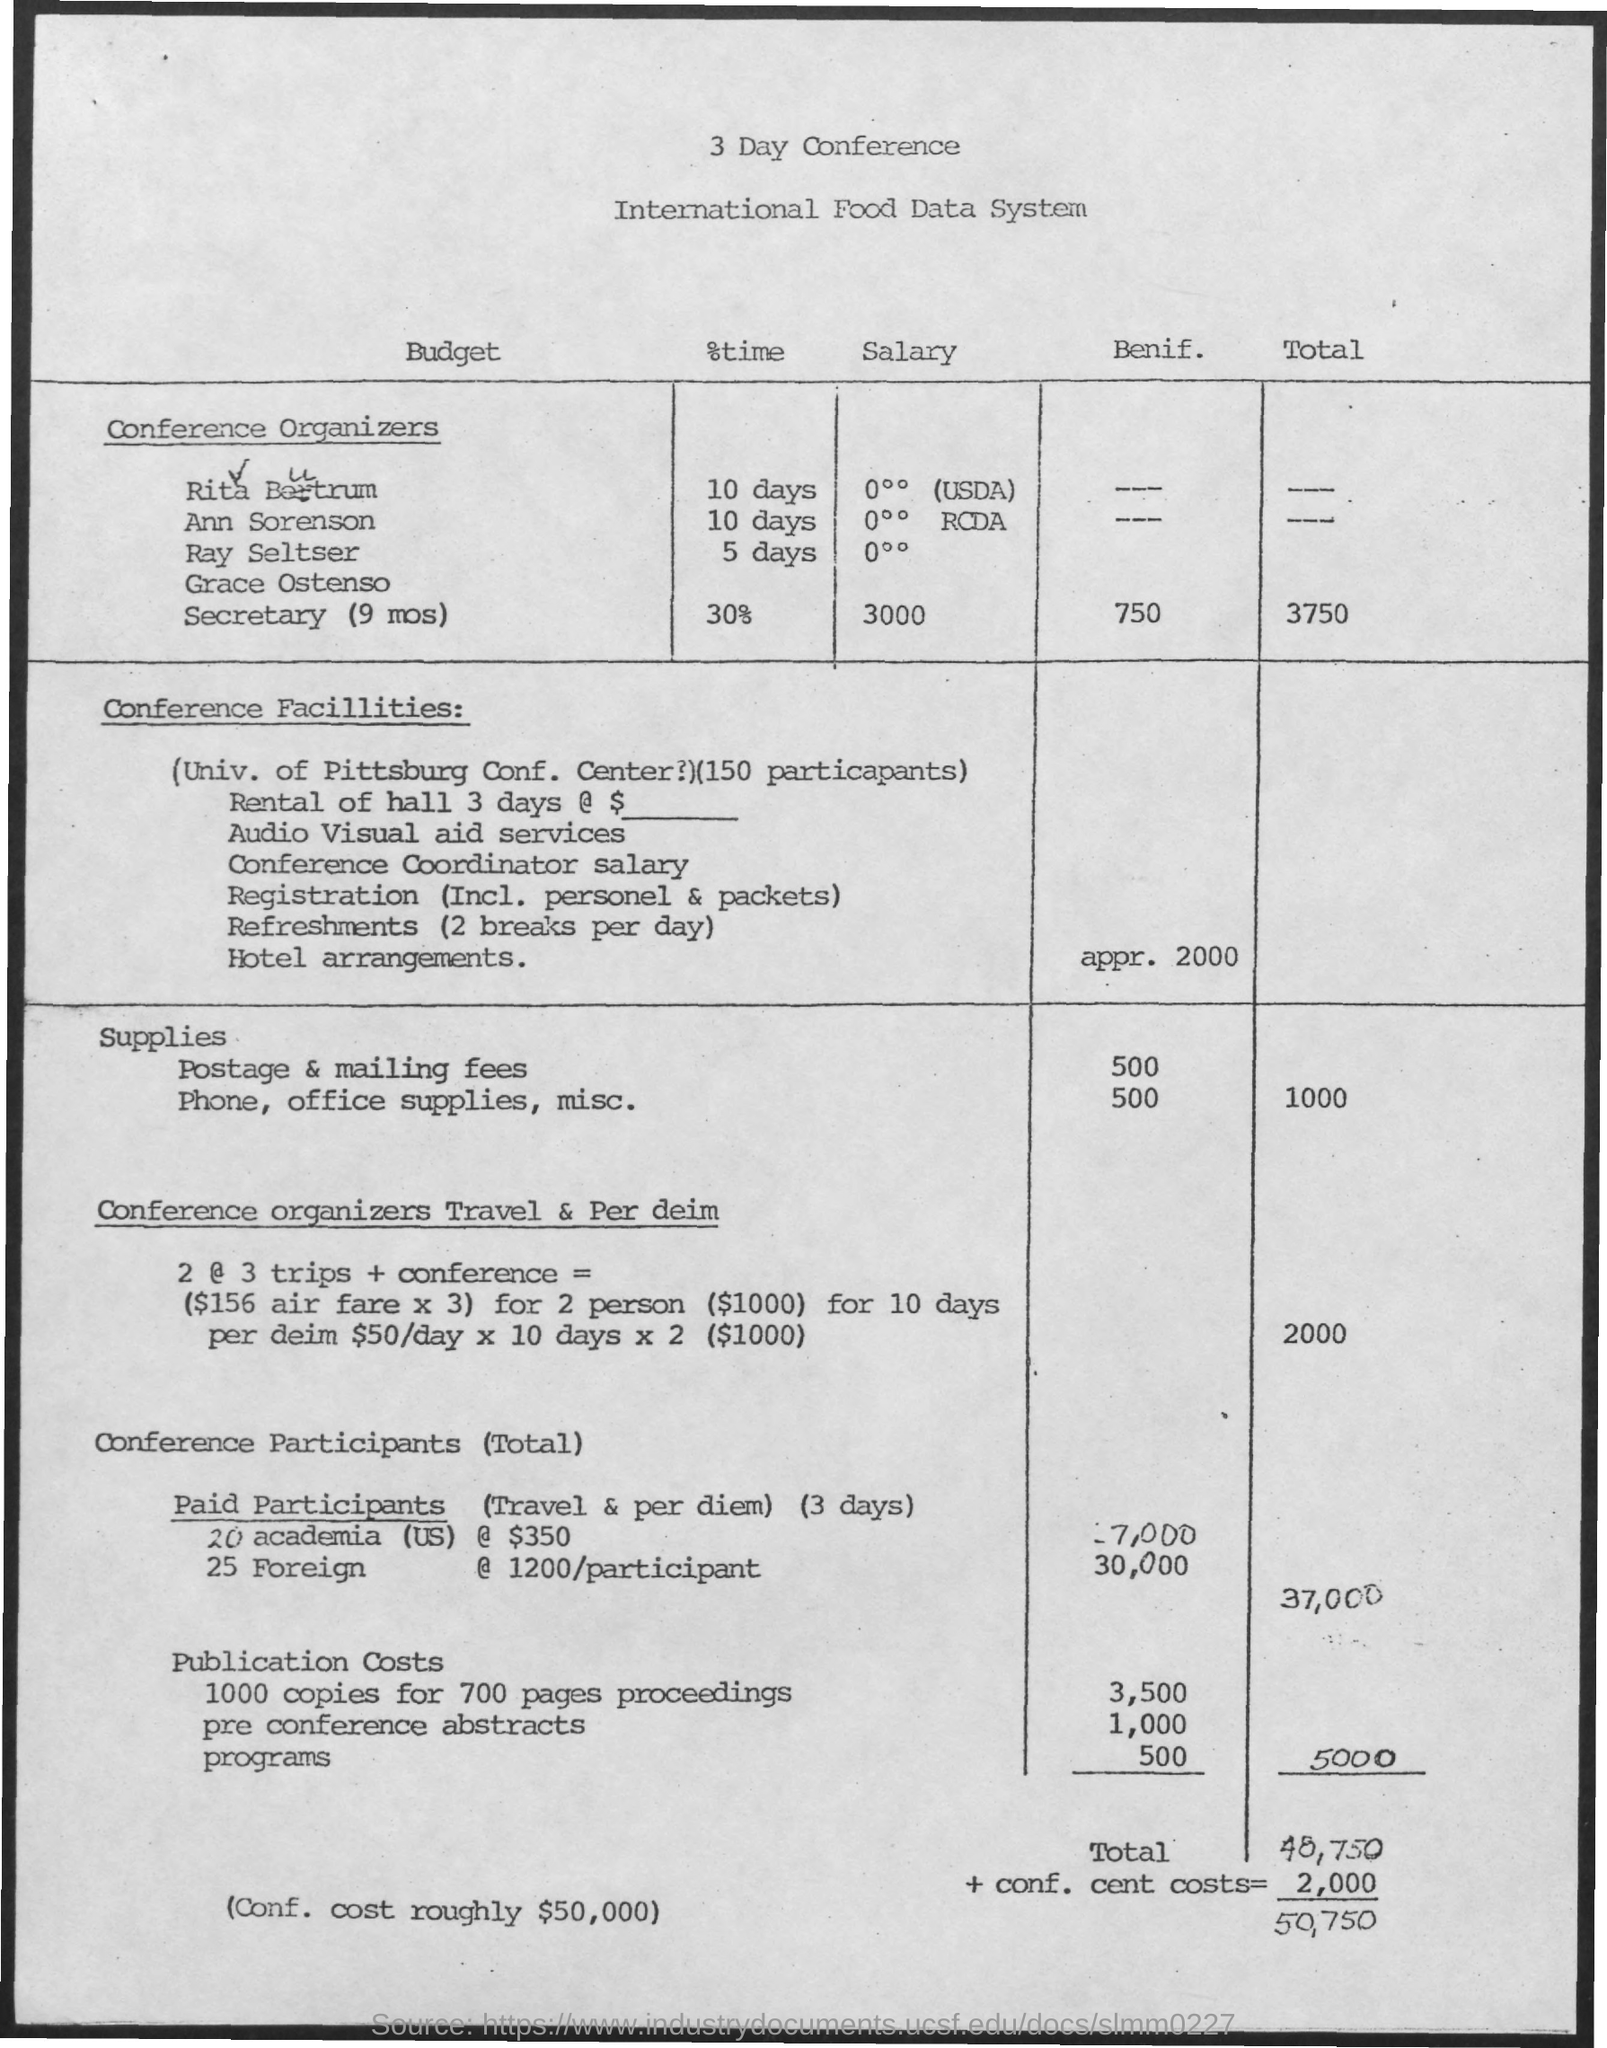Outline some significant characteristics in this image. The total cost, including congressional cent costs, is approximately $50,750. The conference will last for three days. The conference is focused on the International Food Data System. 